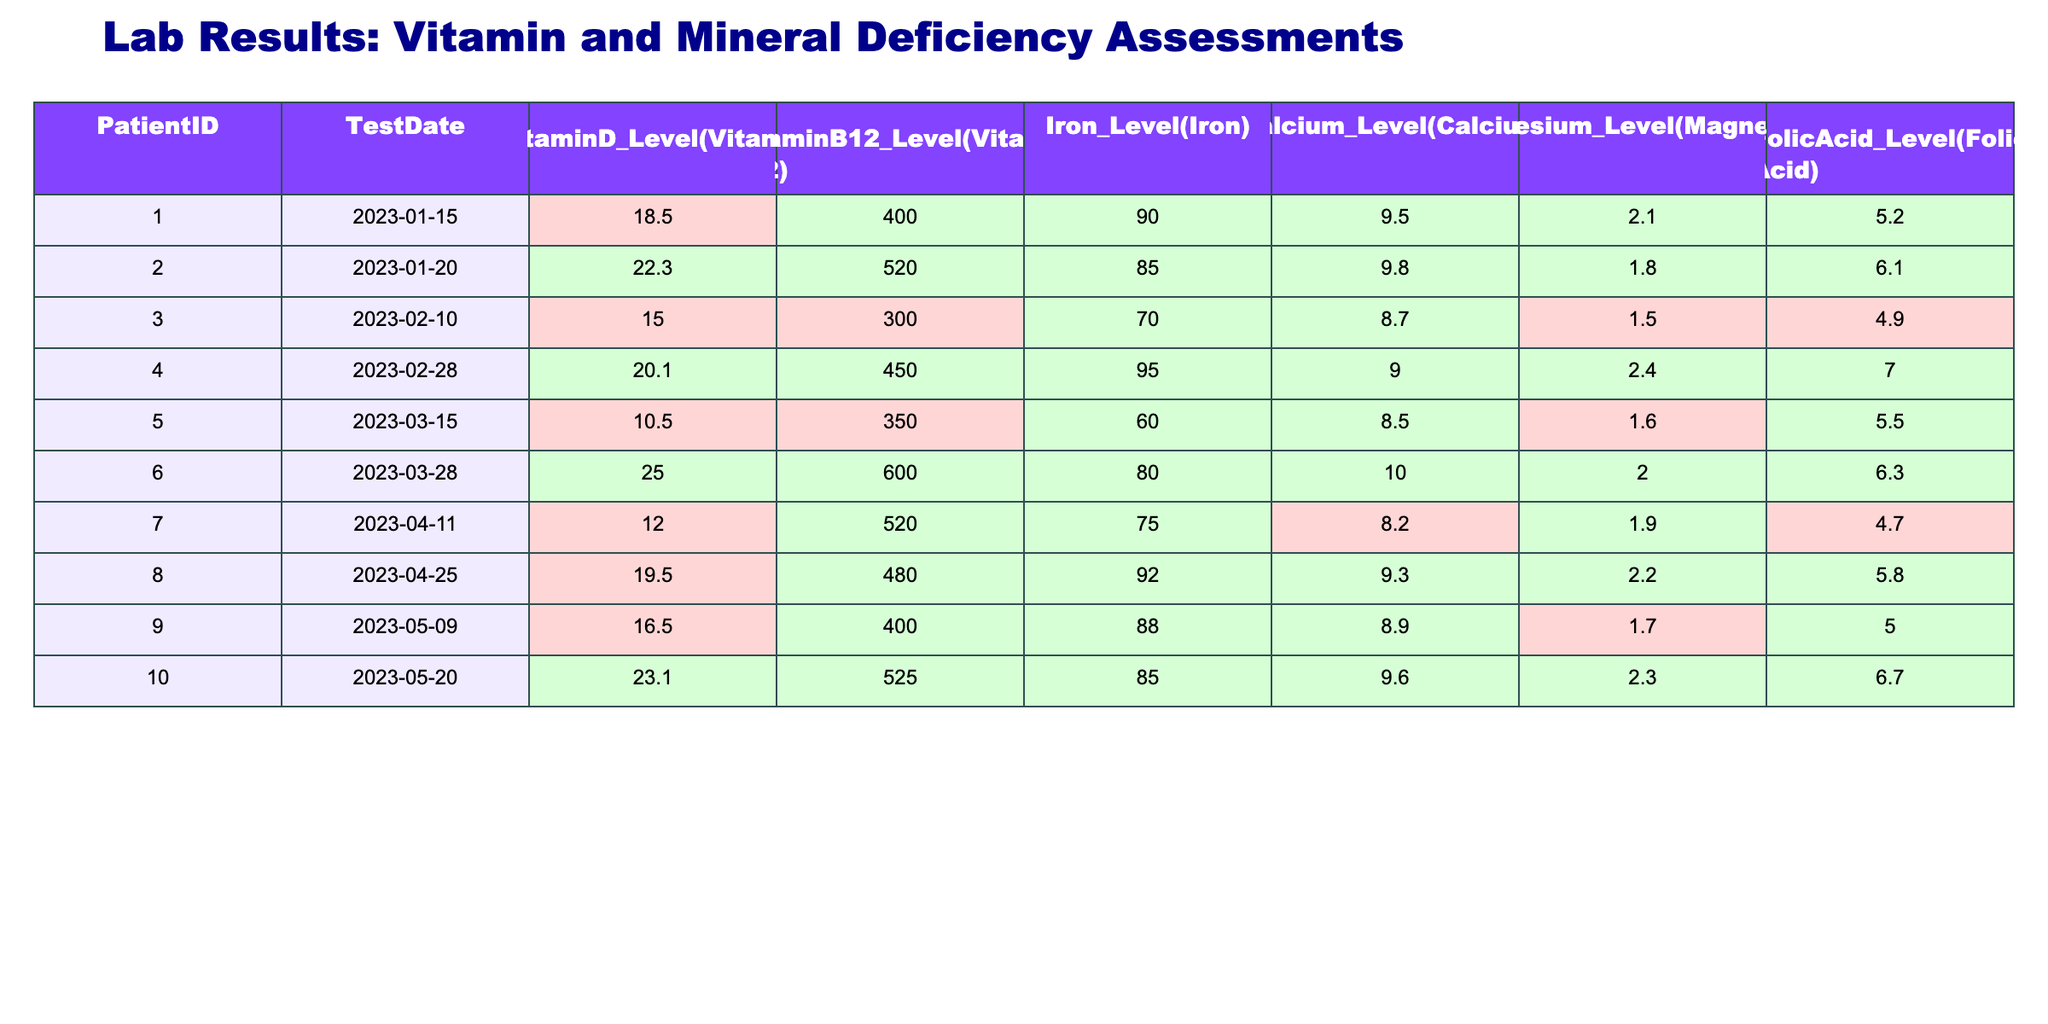What is the Vitamin D level for Patient ID 001? The table shows that for Patient ID 001, the Vitamin D level recorded on 2023-01-15 is 18.5.
Answer: 18.5 Which patient had the highest Vitamin B12 level, and what was it? Looking at the Vitamin B12 levels for all patients, Patient ID 006 has the highest level at 600.
Answer: Patient ID 006, 600 Is there any patient with an Iron level below 70? By reviewing the Iron levels, we see that Patient ID 003 has an Iron level of 70, which is the lowest level recorded, and all others are higher. Therefore, there are no patients with Iron levels below 70.
Answer: No Calculate the average Calcium level of all patients. First, we add all the Calcium levels: (9.5 + 9.8 + 8.7 + 9.0 + 8.5 + 10.0 + 8.2 + 9.3 + 8.9 + 9.6) = 95.5. Since there are 10 patients, the average is 95.5 / 10 = 9.55.
Answer: 9.55 How many patients have a Folic Acid level greater than 5.0? By checking the Folic Acid levels, we find that the patients with levels greater than 5.0 are IDs 002, 004, 006, 008, and 010. That totals to 5 patients.
Answer: 5 What is the difference between the highest and lowest Vitamin D levels? The highest Vitamin D level is 25.0 (Patient ID 006) and the lowest is 10.5 (Patient ID 005). Thus, the difference is 25.0 - 10.5 = 14.5.
Answer: 14.5 Is the average Magnesium level higher than 2.0? The Magnesium levels are: 2.1, 1.8, 1.5, 2.4, 1.6, 2.0, 1.9, 2.2, 1.7, and 2.3. The sum is 2.1 + 1.8 + 1.5 + 2.4 + 1.6 + 2.0 + 1.9 + 2.2 + 1.7 + 2.3 = 19.5. Dividing by 10 gives an average of 1.95, which is not higher than 2.0.
Answer: No Which patient had the lowest Folic Acid level, and what was it? Looking across the Folic Acid levels, Patient ID 003 has the lowest level at 4.9.
Answer: Patient ID 003, 4.9 How many patients had a Calcium level above 9.0? Checking the Calcium levels, the patients who have levels above 9.0 are IDs 001, 002, 004, 006, 008, and 010, totaling to 6 patients.
Answer: 6 